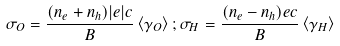<formula> <loc_0><loc_0><loc_500><loc_500>\sigma _ { O } = \frac { ( n _ { e } + n _ { h } ) | e | c } { B } \left < \gamma _ { O } \right > ; \sigma _ { H } = \frac { ( n _ { e } - n _ { h } ) e c } { B } \left < \gamma _ { H } \right ></formula> 